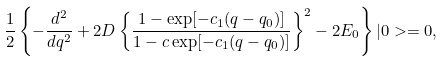Convert formula to latex. <formula><loc_0><loc_0><loc_500><loc_500>\frac { 1 } { 2 } \left \{ - \frac { d ^ { 2 } } { d q ^ { 2 } } + 2 D \left \{ \frac { 1 - \exp [ - c _ { 1 } ( q - q _ { 0 } ) ] } { 1 - c \exp [ - c _ { 1 } ( q - q _ { 0 } ) ] } \right \} ^ { 2 } - 2 E _ { 0 } \right \} | 0 > = 0 ,</formula> 